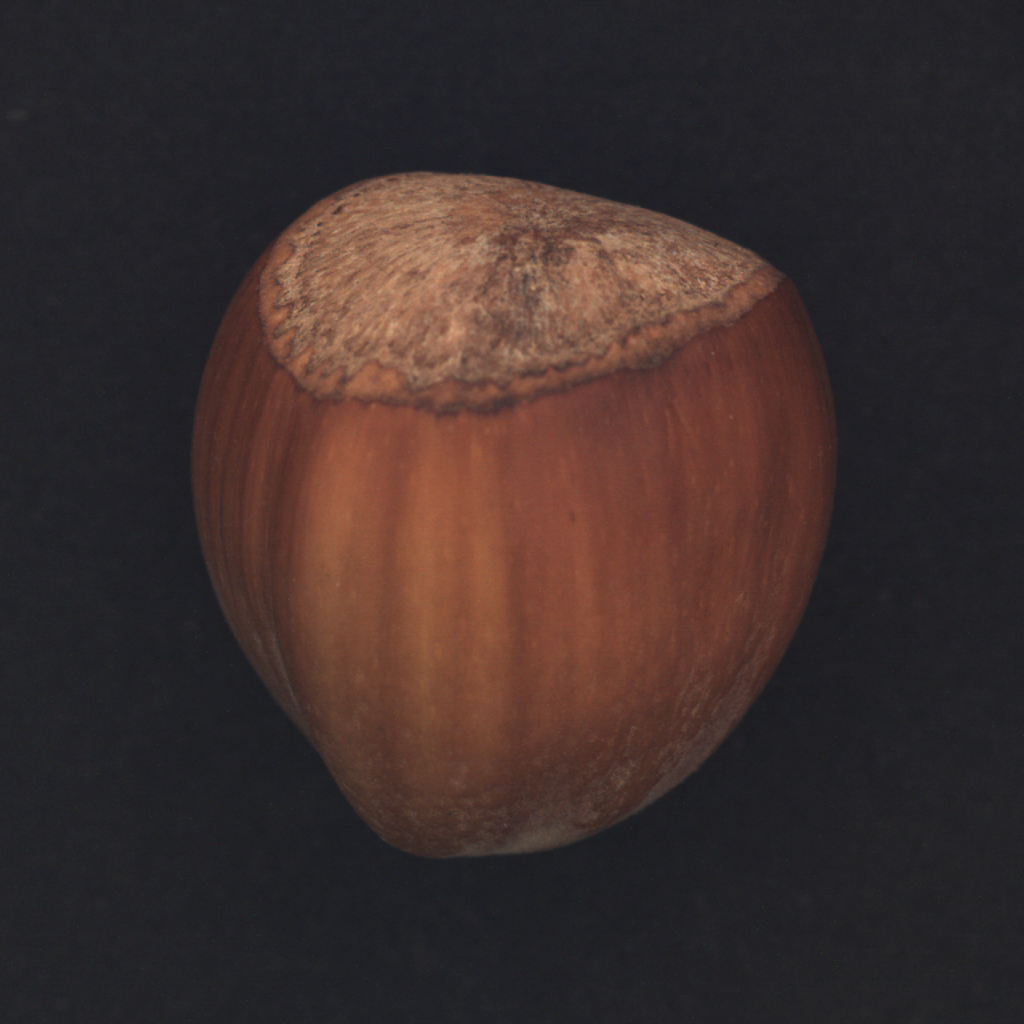What is the significance of the color variation seen in the hazelnut in this image? The variation in color on the surface of a hazelnut from lighter to darker browns is primarily due to the maturity and drying processes of the nut. Initially, hazelnuts are a greenish color when unripe and gradually turn to brown as they mature and lose moisture. The darker shades at the top near the husk are indicators of the seed’s exposure to air and elements, which oxidizes and darkens the shell over time, adding to its rich, woody appearance and texture. This gradient in color not only adds visual depth but also showcases its natural aging process. 